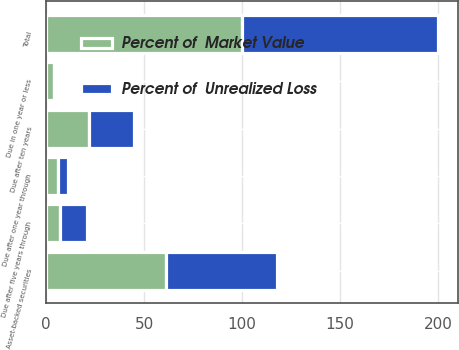Convert chart to OTSL. <chart><loc_0><loc_0><loc_500><loc_500><stacked_bar_chart><ecel><fcel>Due in one year or less<fcel>Due after one year through<fcel>Due after five years through<fcel>Due after ten years<fcel>Asset-backed securities<fcel>Total<nl><fcel>Percent of  Market Value<fcel>4<fcel>6<fcel>7<fcel>22<fcel>61<fcel>100<nl><fcel>Percent of  Unrealized Loss<fcel>1<fcel>5<fcel>14<fcel>23<fcel>57<fcel>100<nl></chart> 